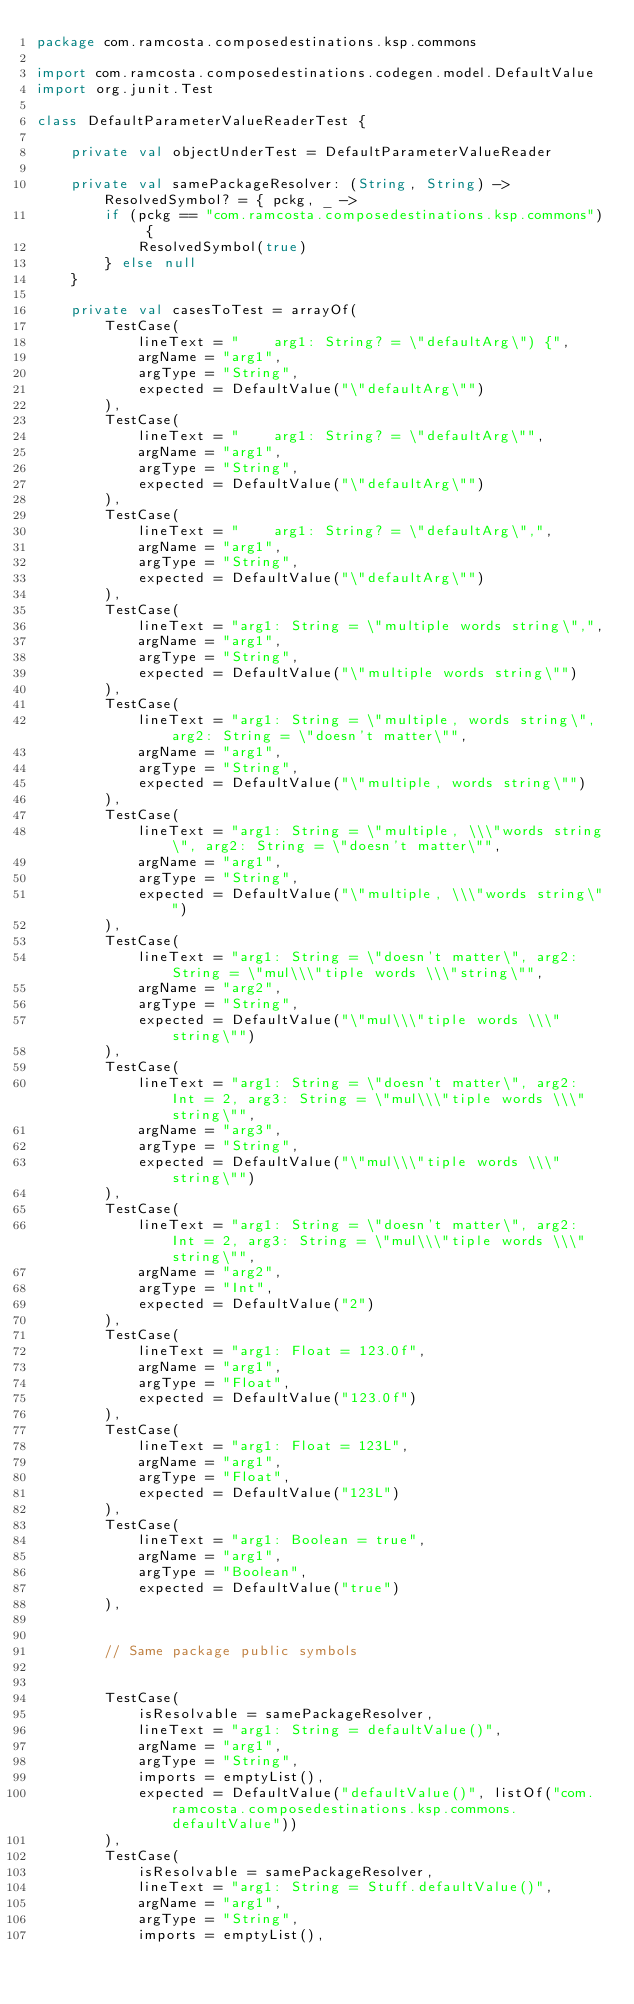Convert code to text. <code><loc_0><loc_0><loc_500><loc_500><_Kotlin_>package com.ramcosta.composedestinations.ksp.commons

import com.ramcosta.composedestinations.codegen.model.DefaultValue
import org.junit.Test

class DefaultParameterValueReaderTest {

    private val objectUnderTest = DefaultParameterValueReader

    private val samePackageResolver: (String, String) -> ResolvedSymbol? = { pckg, _ ->
        if (pckg == "com.ramcosta.composedestinations.ksp.commons") {
            ResolvedSymbol(true)
        } else null
    }

    private val casesToTest = arrayOf(
        TestCase(
            lineText = "    arg1: String? = \"defaultArg\") {",
            argName = "arg1",
            argType = "String",
            expected = DefaultValue("\"defaultArg\"")
        ),
        TestCase(
            lineText = "    arg1: String? = \"defaultArg\"",
            argName = "arg1",
            argType = "String",
            expected = DefaultValue("\"defaultArg\"")
        ),
        TestCase(
            lineText = "    arg1: String? = \"defaultArg\",",
            argName = "arg1",
            argType = "String",
            expected = DefaultValue("\"defaultArg\"")
        ),
        TestCase(
            lineText = "arg1: String = \"multiple words string\",",
            argName = "arg1",
            argType = "String",
            expected = DefaultValue("\"multiple words string\"")
        ),
        TestCase(
            lineText = "arg1: String = \"multiple, words string\", arg2: String = \"doesn't matter\"",
            argName = "arg1",
            argType = "String",
            expected = DefaultValue("\"multiple, words string\"")
        ),
        TestCase(
            lineText = "arg1: String = \"multiple, \\\"words string\", arg2: String = \"doesn't matter\"",
            argName = "arg1",
            argType = "String",
            expected = DefaultValue("\"multiple, \\\"words string\"")
        ),
        TestCase(
            lineText = "arg1: String = \"doesn't matter\", arg2: String = \"mul\\\"tiple words \\\"string\"",
            argName = "arg2",
            argType = "String",
            expected = DefaultValue("\"mul\\\"tiple words \\\"string\"")
        ),
        TestCase(
            lineText = "arg1: String = \"doesn't matter\", arg2: Int = 2, arg3: String = \"mul\\\"tiple words \\\"string\"",
            argName = "arg3",
            argType = "String",
            expected = DefaultValue("\"mul\\\"tiple words \\\"string\"")
        ),
        TestCase(
            lineText = "arg1: String = \"doesn't matter\", arg2: Int = 2, arg3: String = \"mul\\\"tiple words \\\"string\"",
            argName = "arg2",
            argType = "Int",
            expected = DefaultValue("2")
        ),
        TestCase(
            lineText = "arg1: Float = 123.0f",
            argName = "arg1",
            argType = "Float",
            expected = DefaultValue("123.0f")
        ),
        TestCase(
            lineText = "arg1: Float = 123L",
            argName = "arg1",
            argType = "Float",
            expected = DefaultValue("123L")
        ),
        TestCase(
            lineText = "arg1: Boolean = true",
            argName = "arg1",
            argType = "Boolean",
            expected = DefaultValue("true")
        ),


        // Same package public symbols


        TestCase(
            isResolvable = samePackageResolver,
            lineText = "arg1: String = defaultValue()",
            argName = "arg1",
            argType = "String",
            imports = emptyList(),
            expected = DefaultValue("defaultValue()", listOf("com.ramcosta.composedestinations.ksp.commons.defaultValue"))
        ),
        TestCase(
            isResolvable = samePackageResolver,
            lineText = "arg1: String = Stuff.defaultValue()",
            argName = "arg1",
            argType = "String",
            imports = emptyList(),</code> 